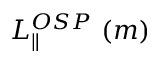Convert formula to latex. <formula><loc_0><loc_0><loc_500><loc_500>L _ { \| } ^ { O S P } ( m )</formula> 